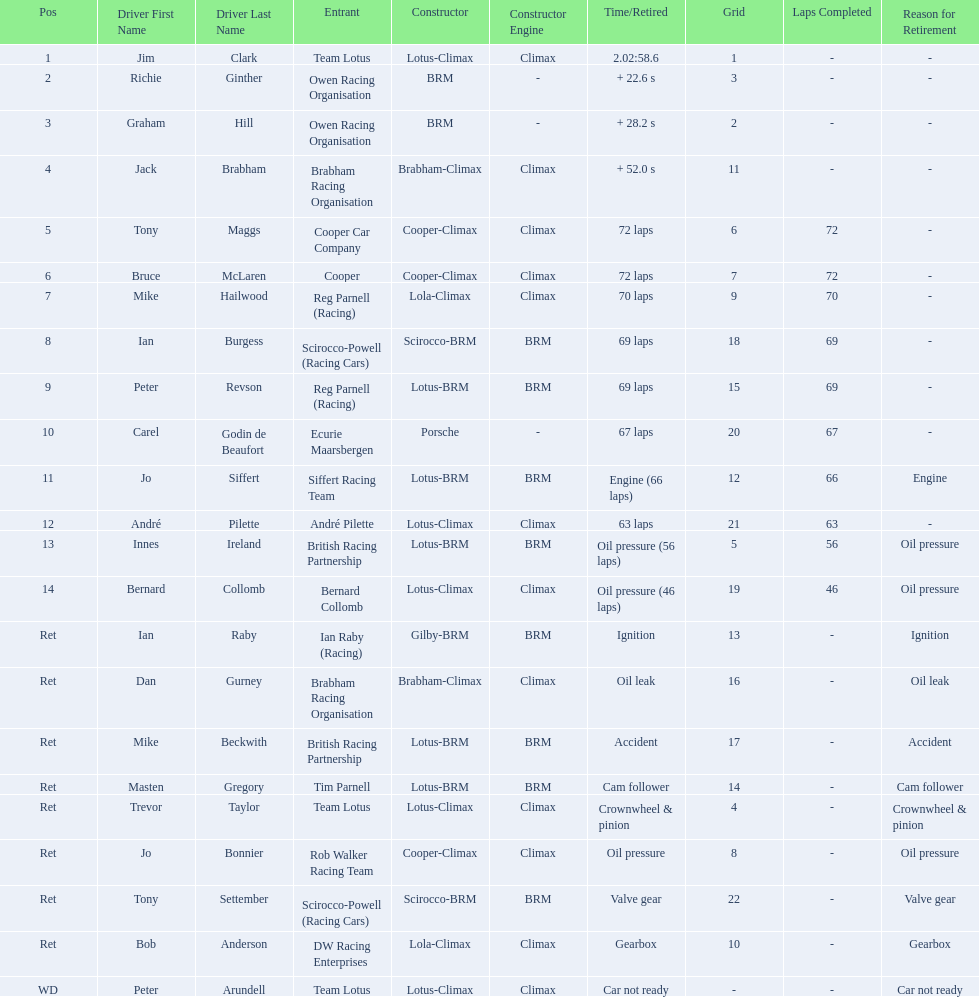Who drove in the 1963 international gold cup? Jim Clark, Richie Ginther, Graham Hill, Jack Brabham, Tony Maggs, Bruce McLaren, Mike Hailwood, Ian Burgess, Peter Revson, Carel Godin de Beaufort, Jo Siffert, André Pilette, Innes Ireland, Bernard Collomb, Ian Raby, Dan Gurney, Mike Beckwith, Masten Gregory, Trevor Taylor, Jo Bonnier, Tony Settember, Bob Anderson, Peter Arundell. Who had problems during the race? Jo Siffert, Innes Ireland, Bernard Collomb, Ian Raby, Dan Gurney, Mike Beckwith, Masten Gregory, Trevor Taylor, Jo Bonnier, Tony Settember, Bob Anderson, Peter Arundell. Of those who was still able to finish the race? Jo Siffert, Innes Ireland, Bernard Collomb. Of those who faced the same issue? Innes Ireland, Bernard Collomb. What issue did they have? Oil pressure. 